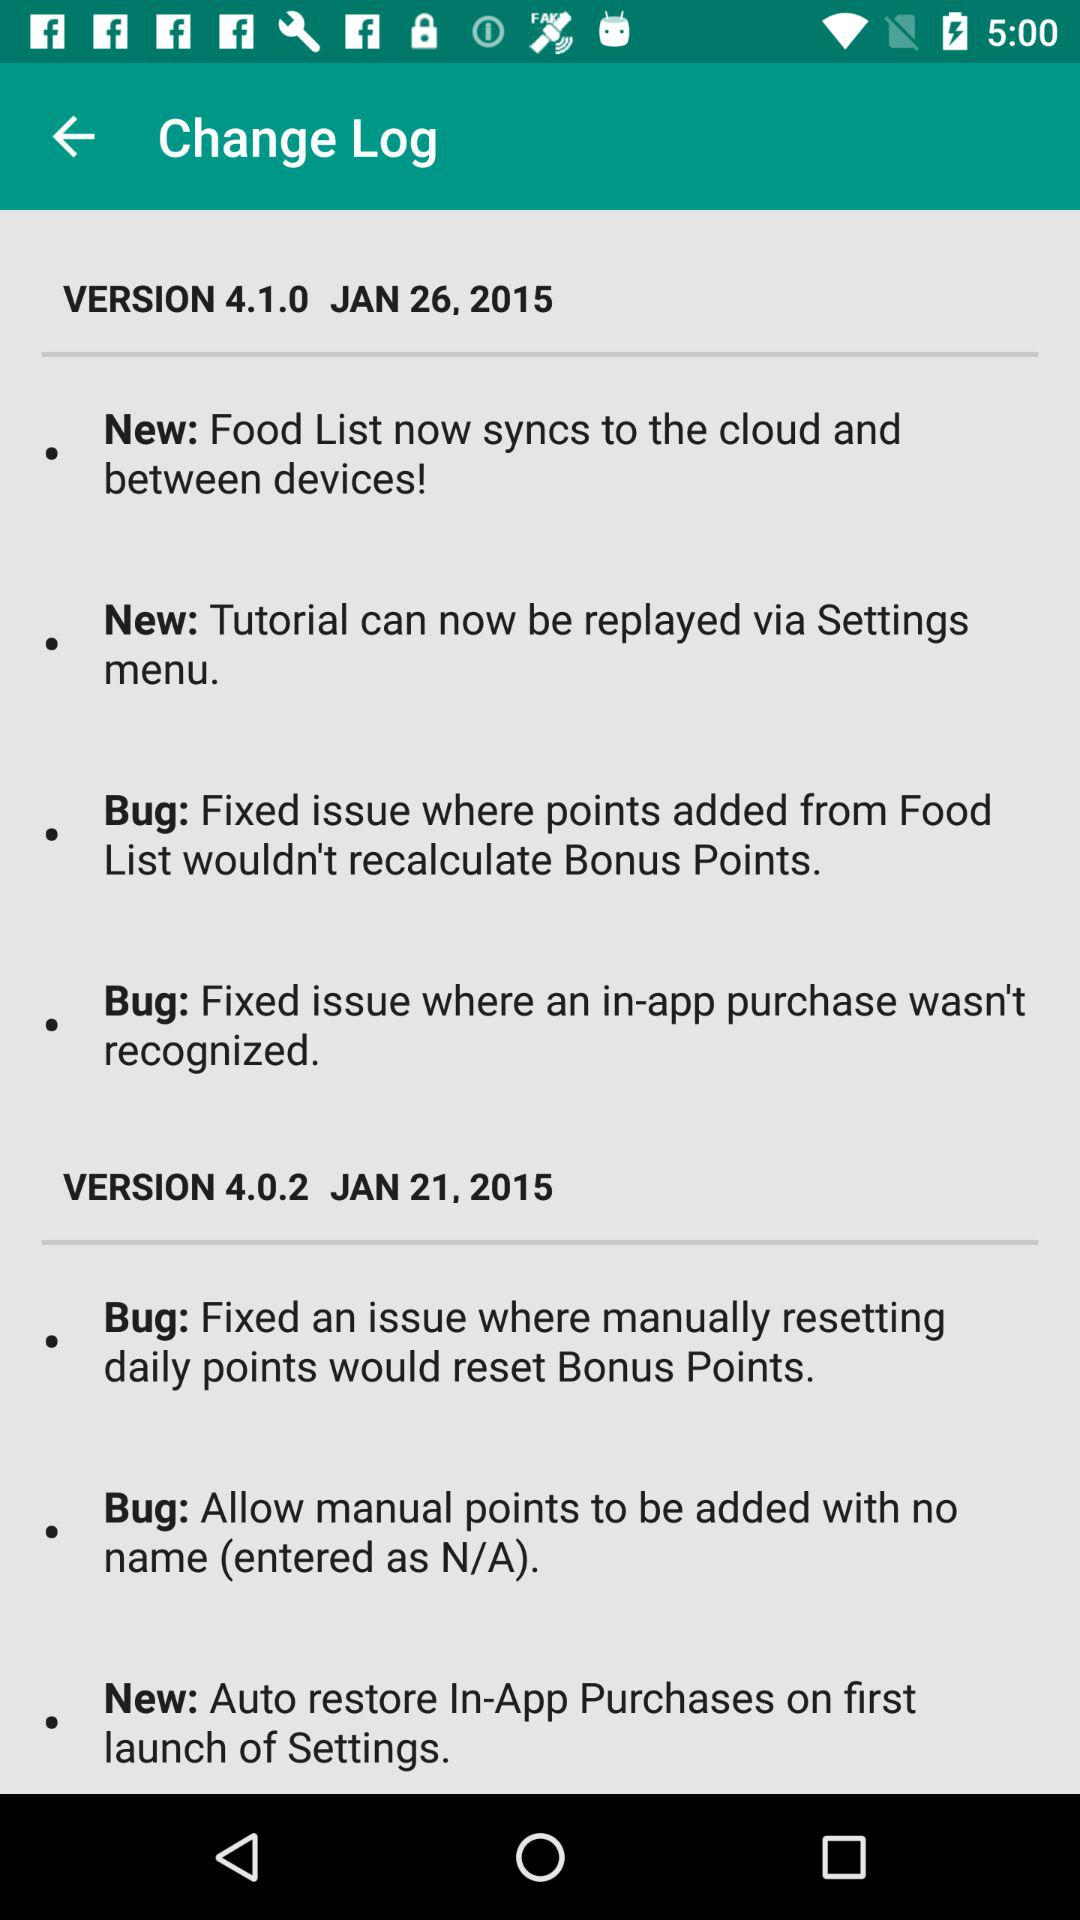What is the name of the application?
When the provided information is insufficient, respond with <no answer>. <no answer> 